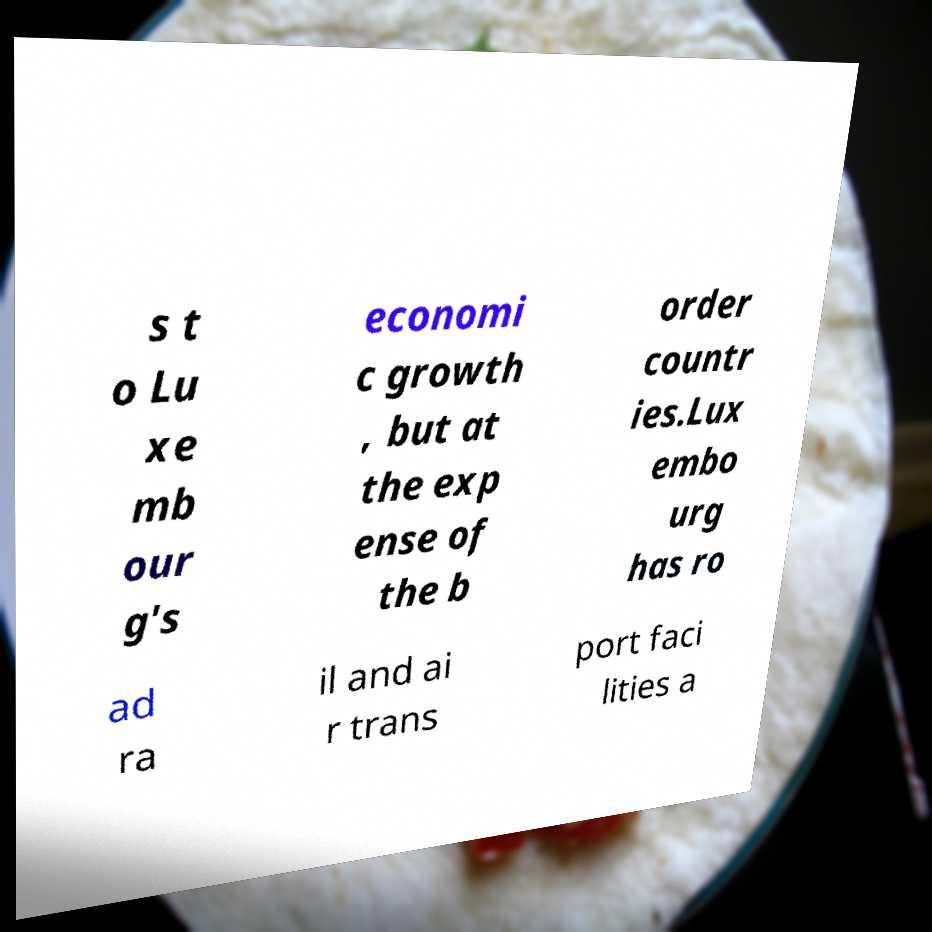There's text embedded in this image that I need extracted. Can you transcribe it verbatim? s t o Lu xe mb our g's economi c growth , but at the exp ense of the b order countr ies.Lux embo urg has ro ad ra il and ai r trans port faci lities a 